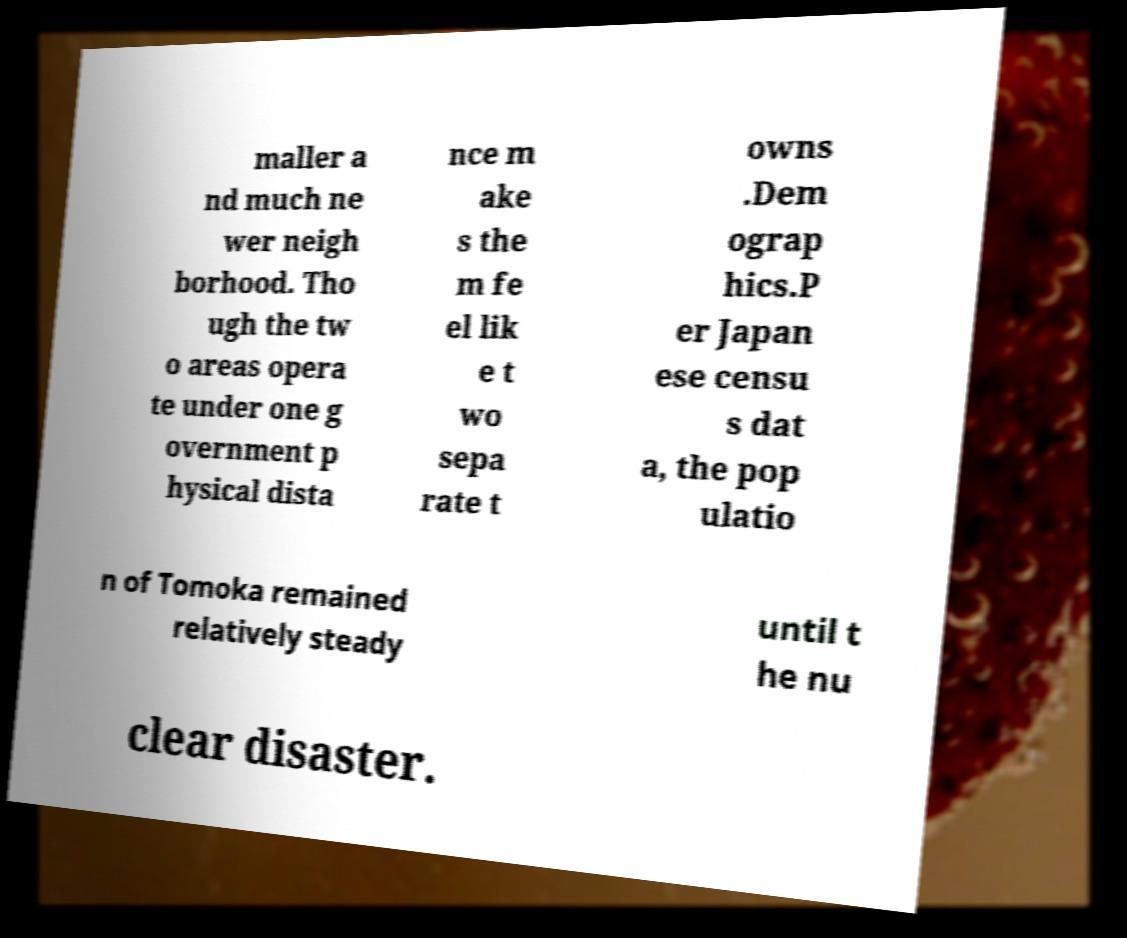Can you accurately transcribe the text from the provided image for me? maller a nd much ne wer neigh borhood. Tho ugh the tw o areas opera te under one g overnment p hysical dista nce m ake s the m fe el lik e t wo sepa rate t owns .Dem ograp hics.P er Japan ese censu s dat a, the pop ulatio n of Tomoka remained relatively steady until t he nu clear disaster. 